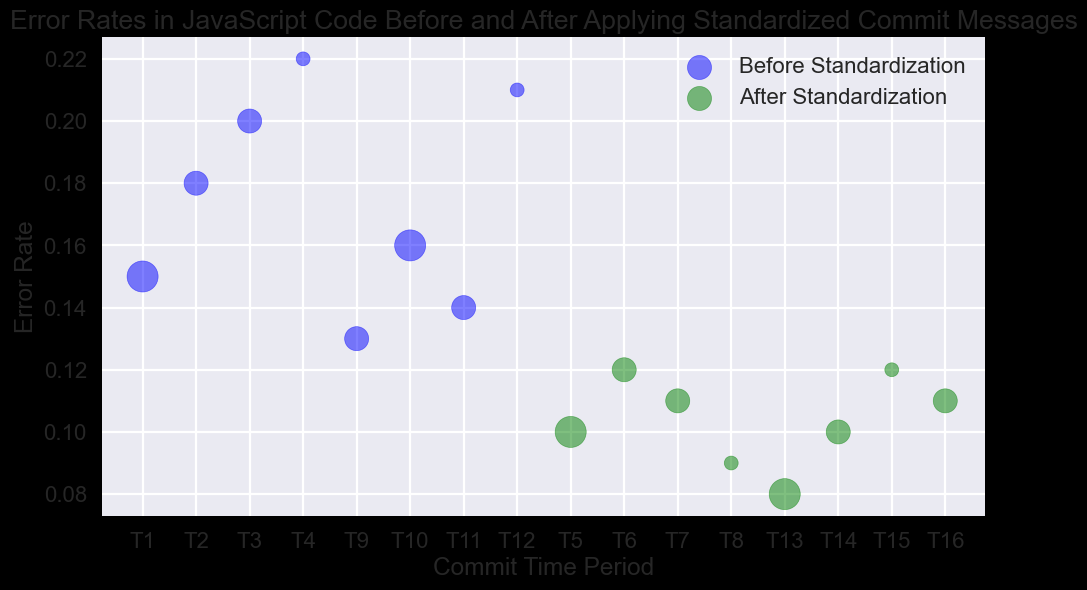What’s the general trend in error rates before and after applying standardized commit messages? To find this, observe the positioning of the bubbles in the before and after categories. The bubbles for 'before' standardization are generally at higher error rates (e.g., ranging from 0.14 to 0.22). The bubbles for 'after' standardization are generally at lower error rates (e.g., ranging from 0.08 to 0.13). The overall trend is that error rates decrease after standardization.
Answer: Error rates decrease Which time period shows the highest error rate before standardization? Look at the vertical positions of the blue bubbles (representing 'before' standardization) to identify the highest point on the y-axis. The highest error rate before standardization is at T4 with an error rate of 0.22.
Answer: T4 By how much did the error rate change between T3 and T7? First, identify the error rates at T3 and T7. At T3 (before standardization), the error rate is 0.20. At T7 (after standardization), the error rate is 0.11. The rate decreased by 0.20 - 0.11 = 0.09.
Answer: 0.09 Which set has a higher proportion of bubbles with 'high' importance, before or after standardization? Count the blue bubbles and green bubbles of size 500 (which signifies 'high' importance). There are two in 'before' and two in 'after'. Since both have an equal number of high importance bubbles, we compare the total count. There are nine 'before' bubbles and seven 'after' bubbles, making the proportion: 2/9 for 'before' and 2/7 for 'after'. The higher proportion is 2/7.
Answer: after Is there a time period where the error rate before standardization equals the highest error rate after standardization? The error rates before standardization are 0.15, 0.18, 0.20, 0.22, 0.13, 0.16, 0.14, and 0.21. The highest error rate after standardization is 0.13. The error rate of 0.13 (before) is equal to the maximum error rate (0.13) after. This happens at T9.
Answer: T9 Are there any bubbles representing error rates of 0.10, bridging both before and after standardization? Look for bubbles at the 0.10 error rate on the y-axis in both blue and green. There is a blue bubble (before) at T5 and green bubbles (after) at T5 and T14. Thus, both before and after contain bubbles at an error rate of 0.10.
Answer: Yes 